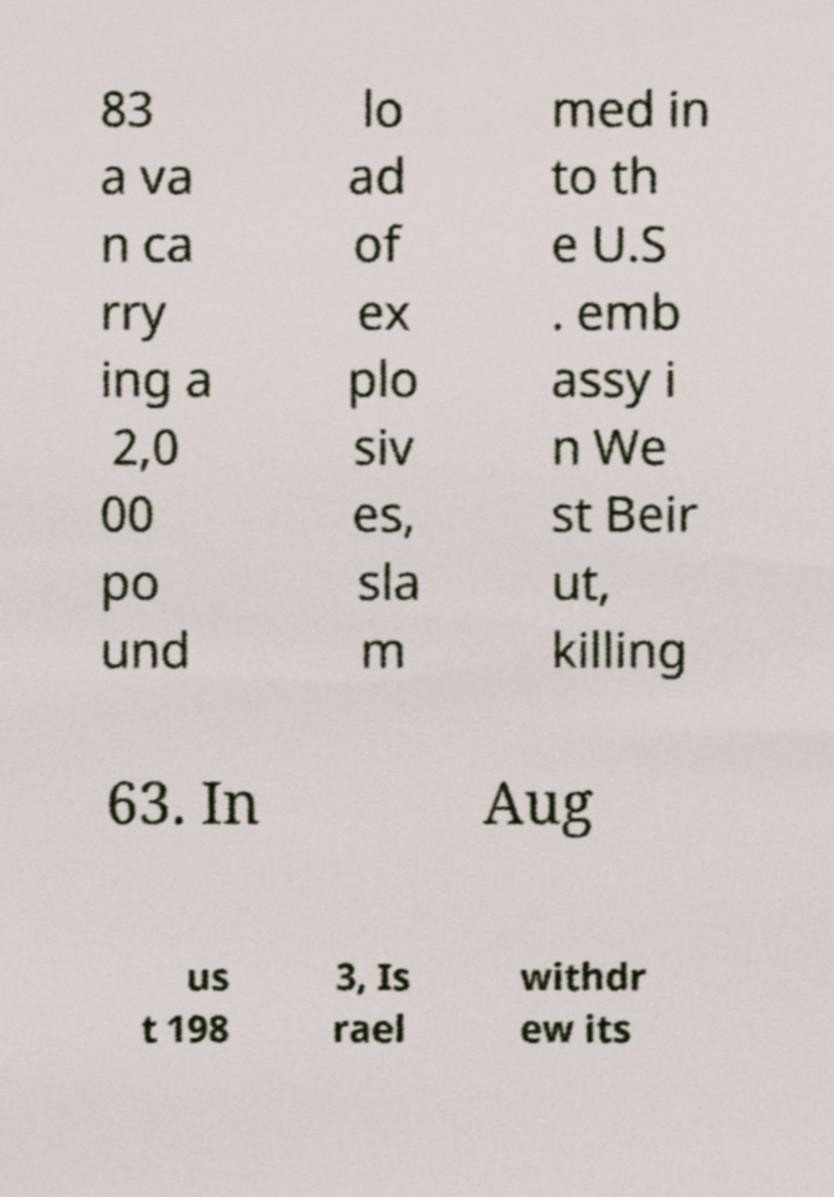Please read and relay the text visible in this image. What does it say? 83 a va n ca rry ing a 2,0 00 po und lo ad of ex plo siv es, sla m med in to th e U.S . emb assy i n We st Beir ut, killing 63. In Aug us t 198 3, Is rael withdr ew its 